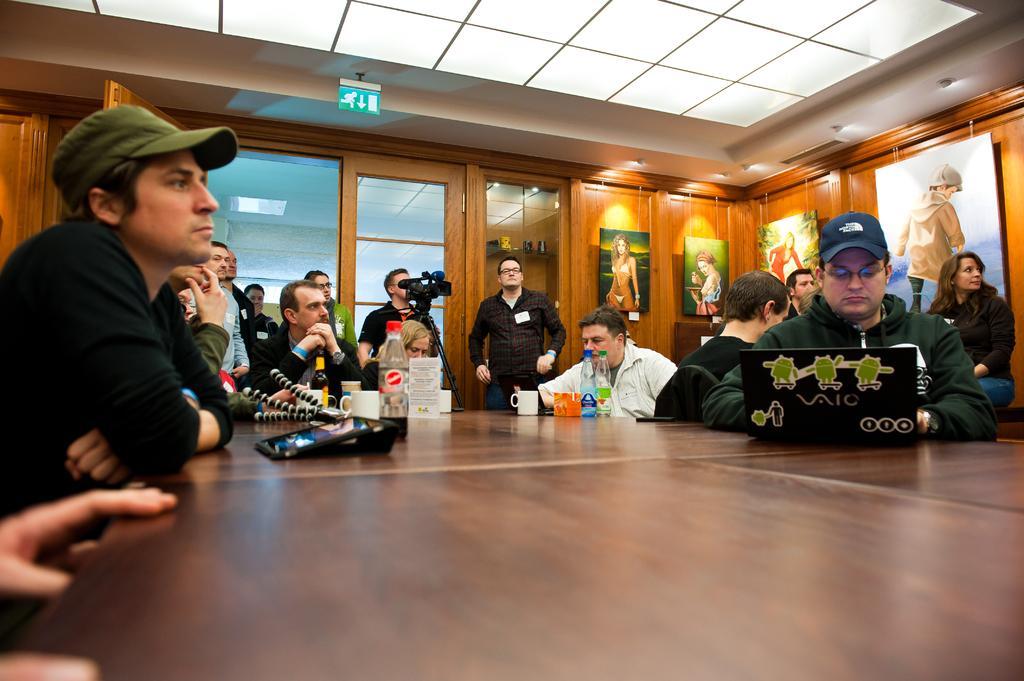Please provide a concise description of this image. In the image we can see there are people who are sitting on chair. In Front of them there is a laptop and the others are standing and taking the video. 